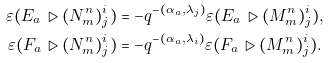Convert formula to latex. <formula><loc_0><loc_0><loc_500><loc_500>\varepsilon ( E _ { a } \triangleright ( N ^ { n } _ { m } ) ^ { i } _ { j } ) & = - q ^ { - ( \alpha _ { a } , \lambda _ { j } ) } \varepsilon ( E _ { a } \triangleright ( M ^ { n } _ { m } ) ^ { i } _ { j } ) , \\ \varepsilon ( F _ { a } \triangleright ( N ^ { n } _ { m } ) ^ { i } _ { j } ) & = - q ^ { - ( \alpha _ { a } , \lambda _ { i } ) } \varepsilon ( F _ { a } \triangleright ( M ^ { n } _ { m } ) ^ { i } _ { j } ) .</formula> 